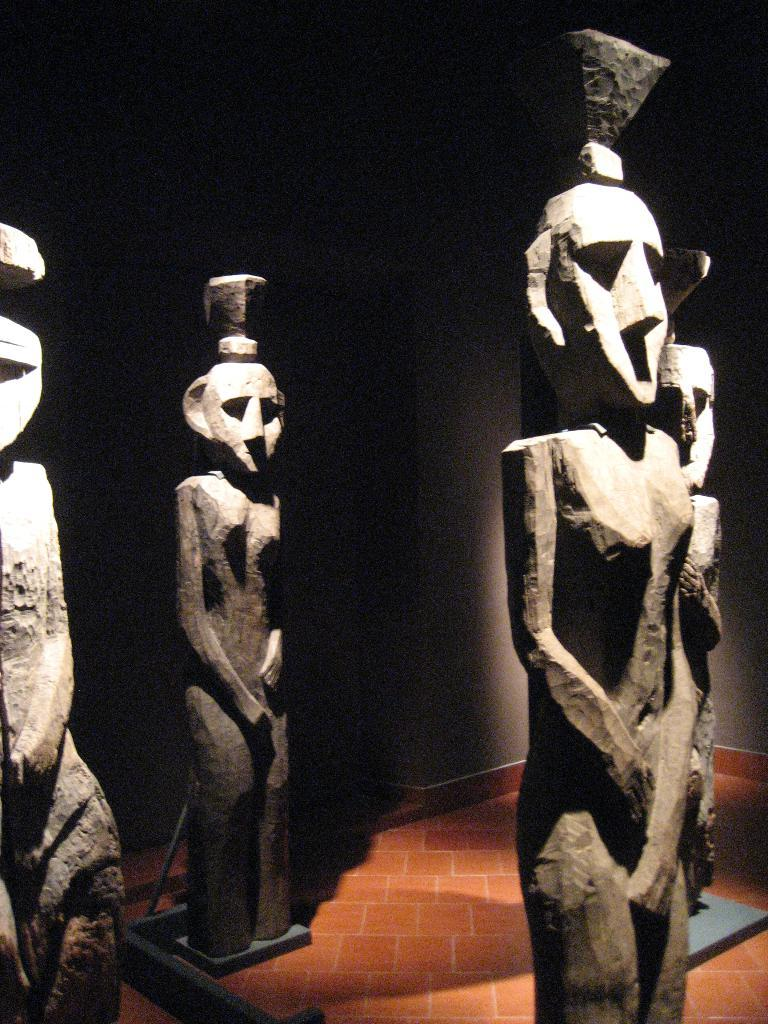What can be seen in the image? There are statues in the image. What is visible in the background of the image? There is a wall in the background of the image. How many frogs are jumping in the air in the image? There are no frogs present in the image, so it is not possible to determine the number of frogs jumping in the air. 